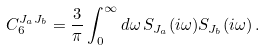Convert formula to latex. <formula><loc_0><loc_0><loc_500><loc_500>C _ { 6 } ^ { J _ { a } J _ { b } } = \frac { 3 } { \pi } \int _ { 0 } ^ { \infty } d \omega \, S _ { J _ { a } } ( i \omega ) S _ { J _ { b } } ( i \omega ) \, .</formula> 